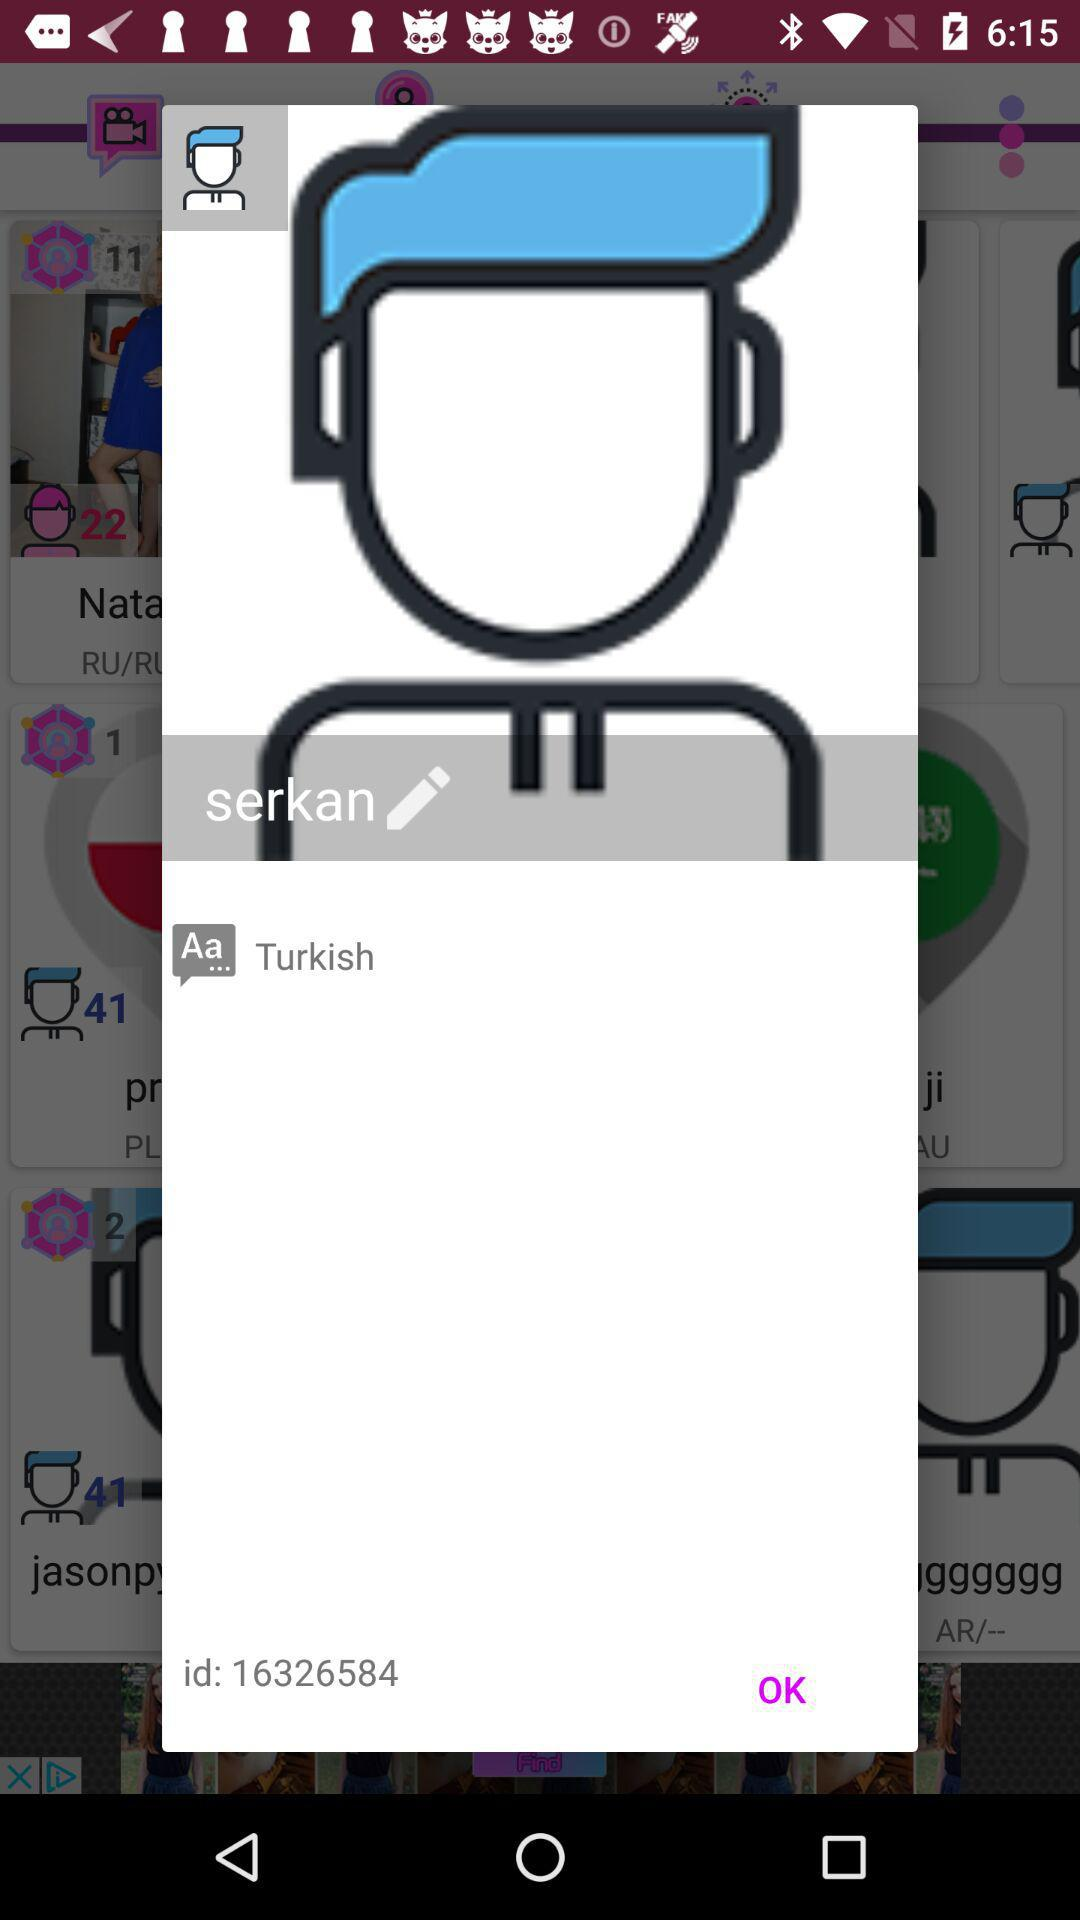What is the id? The id is 16326584. 